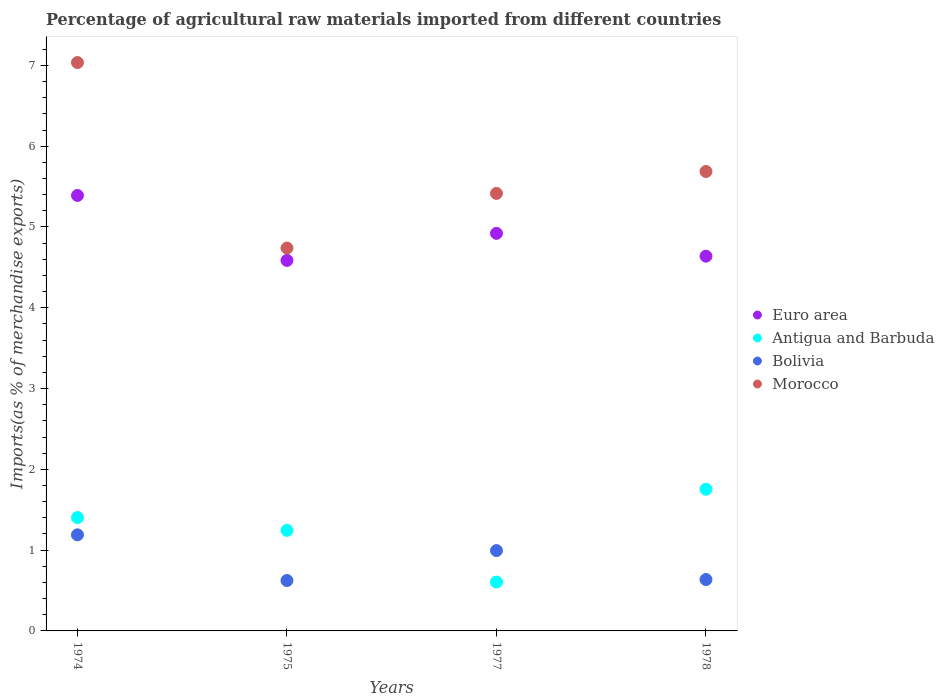What is the percentage of imports to different countries in Antigua and Barbuda in 1974?
Ensure brevity in your answer.  1.4. Across all years, what is the maximum percentage of imports to different countries in Morocco?
Your answer should be very brief. 7.04. Across all years, what is the minimum percentage of imports to different countries in Bolivia?
Keep it short and to the point. 0.62. In which year was the percentage of imports to different countries in Antigua and Barbuda maximum?
Make the answer very short. 1978. In which year was the percentage of imports to different countries in Bolivia minimum?
Make the answer very short. 1975. What is the total percentage of imports to different countries in Euro area in the graph?
Provide a succinct answer. 19.54. What is the difference between the percentage of imports to different countries in Morocco in 1974 and that in 1977?
Your response must be concise. 1.62. What is the difference between the percentage of imports to different countries in Antigua and Barbuda in 1978 and the percentage of imports to different countries in Euro area in 1974?
Provide a short and direct response. -3.64. What is the average percentage of imports to different countries in Bolivia per year?
Give a very brief answer. 0.86. In the year 1977, what is the difference between the percentage of imports to different countries in Euro area and percentage of imports to different countries in Bolivia?
Your answer should be very brief. 3.93. What is the ratio of the percentage of imports to different countries in Antigua and Barbuda in 1977 to that in 1978?
Your answer should be compact. 0.34. Is the difference between the percentage of imports to different countries in Euro area in 1975 and 1977 greater than the difference between the percentage of imports to different countries in Bolivia in 1975 and 1977?
Your response must be concise. Yes. What is the difference between the highest and the second highest percentage of imports to different countries in Bolivia?
Give a very brief answer. 0.2. What is the difference between the highest and the lowest percentage of imports to different countries in Bolivia?
Offer a very short reply. 0.57. In how many years, is the percentage of imports to different countries in Bolivia greater than the average percentage of imports to different countries in Bolivia taken over all years?
Your answer should be compact. 2. How many dotlines are there?
Keep it short and to the point. 4. How many years are there in the graph?
Provide a short and direct response. 4. Are the values on the major ticks of Y-axis written in scientific E-notation?
Provide a short and direct response. No. Does the graph contain grids?
Ensure brevity in your answer.  No. How many legend labels are there?
Ensure brevity in your answer.  4. What is the title of the graph?
Your response must be concise. Percentage of agricultural raw materials imported from different countries. What is the label or title of the X-axis?
Provide a succinct answer. Years. What is the label or title of the Y-axis?
Offer a very short reply. Imports(as % of merchandise exports). What is the Imports(as % of merchandise exports) of Euro area in 1974?
Your answer should be compact. 5.39. What is the Imports(as % of merchandise exports) in Antigua and Barbuda in 1974?
Your answer should be very brief. 1.4. What is the Imports(as % of merchandise exports) of Bolivia in 1974?
Offer a terse response. 1.19. What is the Imports(as % of merchandise exports) of Morocco in 1974?
Ensure brevity in your answer.  7.04. What is the Imports(as % of merchandise exports) in Euro area in 1975?
Provide a short and direct response. 4.59. What is the Imports(as % of merchandise exports) in Antigua and Barbuda in 1975?
Provide a succinct answer. 1.25. What is the Imports(as % of merchandise exports) in Bolivia in 1975?
Your response must be concise. 0.62. What is the Imports(as % of merchandise exports) of Morocco in 1975?
Provide a succinct answer. 4.74. What is the Imports(as % of merchandise exports) in Euro area in 1977?
Your response must be concise. 4.92. What is the Imports(as % of merchandise exports) in Antigua and Barbuda in 1977?
Offer a terse response. 0.6. What is the Imports(as % of merchandise exports) of Bolivia in 1977?
Make the answer very short. 0.99. What is the Imports(as % of merchandise exports) of Morocco in 1977?
Provide a succinct answer. 5.42. What is the Imports(as % of merchandise exports) of Euro area in 1978?
Your answer should be compact. 4.64. What is the Imports(as % of merchandise exports) of Antigua and Barbuda in 1978?
Your response must be concise. 1.75. What is the Imports(as % of merchandise exports) of Bolivia in 1978?
Provide a short and direct response. 0.64. What is the Imports(as % of merchandise exports) of Morocco in 1978?
Give a very brief answer. 5.69. Across all years, what is the maximum Imports(as % of merchandise exports) in Euro area?
Ensure brevity in your answer.  5.39. Across all years, what is the maximum Imports(as % of merchandise exports) of Antigua and Barbuda?
Your answer should be very brief. 1.75. Across all years, what is the maximum Imports(as % of merchandise exports) in Bolivia?
Your answer should be compact. 1.19. Across all years, what is the maximum Imports(as % of merchandise exports) in Morocco?
Your answer should be very brief. 7.04. Across all years, what is the minimum Imports(as % of merchandise exports) of Euro area?
Provide a succinct answer. 4.59. Across all years, what is the minimum Imports(as % of merchandise exports) in Antigua and Barbuda?
Your response must be concise. 0.6. Across all years, what is the minimum Imports(as % of merchandise exports) in Bolivia?
Ensure brevity in your answer.  0.62. Across all years, what is the minimum Imports(as % of merchandise exports) of Morocco?
Keep it short and to the point. 4.74. What is the total Imports(as % of merchandise exports) in Euro area in the graph?
Keep it short and to the point. 19.54. What is the total Imports(as % of merchandise exports) in Antigua and Barbuda in the graph?
Give a very brief answer. 5.01. What is the total Imports(as % of merchandise exports) in Bolivia in the graph?
Ensure brevity in your answer.  3.44. What is the total Imports(as % of merchandise exports) of Morocco in the graph?
Provide a succinct answer. 22.88. What is the difference between the Imports(as % of merchandise exports) of Euro area in 1974 and that in 1975?
Offer a terse response. 0.8. What is the difference between the Imports(as % of merchandise exports) of Antigua and Barbuda in 1974 and that in 1975?
Your response must be concise. 0.16. What is the difference between the Imports(as % of merchandise exports) of Bolivia in 1974 and that in 1975?
Ensure brevity in your answer.  0.57. What is the difference between the Imports(as % of merchandise exports) in Morocco in 1974 and that in 1975?
Offer a very short reply. 2.3. What is the difference between the Imports(as % of merchandise exports) of Euro area in 1974 and that in 1977?
Make the answer very short. 0.47. What is the difference between the Imports(as % of merchandise exports) in Antigua and Barbuda in 1974 and that in 1977?
Give a very brief answer. 0.8. What is the difference between the Imports(as % of merchandise exports) of Bolivia in 1974 and that in 1977?
Offer a very short reply. 0.2. What is the difference between the Imports(as % of merchandise exports) in Morocco in 1974 and that in 1977?
Offer a terse response. 1.62. What is the difference between the Imports(as % of merchandise exports) in Euro area in 1974 and that in 1978?
Your response must be concise. 0.75. What is the difference between the Imports(as % of merchandise exports) in Antigua and Barbuda in 1974 and that in 1978?
Provide a short and direct response. -0.35. What is the difference between the Imports(as % of merchandise exports) of Bolivia in 1974 and that in 1978?
Make the answer very short. 0.55. What is the difference between the Imports(as % of merchandise exports) in Morocco in 1974 and that in 1978?
Provide a short and direct response. 1.35. What is the difference between the Imports(as % of merchandise exports) of Euro area in 1975 and that in 1977?
Keep it short and to the point. -0.33. What is the difference between the Imports(as % of merchandise exports) in Antigua and Barbuda in 1975 and that in 1977?
Provide a succinct answer. 0.64. What is the difference between the Imports(as % of merchandise exports) in Bolivia in 1975 and that in 1977?
Your answer should be very brief. -0.37. What is the difference between the Imports(as % of merchandise exports) of Morocco in 1975 and that in 1977?
Provide a succinct answer. -0.68. What is the difference between the Imports(as % of merchandise exports) of Euro area in 1975 and that in 1978?
Provide a short and direct response. -0.05. What is the difference between the Imports(as % of merchandise exports) in Antigua and Barbuda in 1975 and that in 1978?
Offer a very short reply. -0.51. What is the difference between the Imports(as % of merchandise exports) of Bolivia in 1975 and that in 1978?
Offer a terse response. -0.01. What is the difference between the Imports(as % of merchandise exports) in Morocco in 1975 and that in 1978?
Your answer should be very brief. -0.95. What is the difference between the Imports(as % of merchandise exports) of Euro area in 1977 and that in 1978?
Give a very brief answer. 0.28. What is the difference between the Imports(as % of merchandise exports) of Antigua and Barbuda in 1977 and that in 1978?
Your answer should be compact. -1.15. What is the difference between the Imports(as % of merchandise exports) in Bolivia in 1977 and that in 1978?
Make the answer very short. 0.36. What is the difference between the Imports(as % of merchandise exports) in Morocco in 1977 and that in 1978?
Make the answer very short. -0.27. What is the difference between the Imports(as % of merchandise exports) of Euro area in 1974 and the Imports(as % of merchandise exports) of Antigua and Barbuda in 1975?
Your answer should be very brief. 4.15. What is the difference between the Imports(as % of merchandise exports) of Euro area in 1974 and the Imports(as % of merchandise exports) of Bolivia in 1975?
Make the answer very short. 4.77. What is the difference between the Imports(as % of merchandise exports) in Euro area in 1974 and the Imports(as % of merchandise exports) in Morocco in 1975?
Your response must be concise. 0.65. What is the difference between the Imports(as % of merchandise exports) in Antigua and Barbuda in 1974 and the Imports(as % of merchandise exports) in Bolivia in 1975?
Your answer should be compact. 0.78. What is the difference between the Imports(as % of merchandise exports) of Antigua and Barbuda in 1974 and the Imports(as % of merchandise exports) of Morocco in 1975?
Offer a terse response. -3.34. What is the difference between the Imports(as % of merchandise exports) of Bolivia in 1974 and the Imports(as % of merchandise exports) of Morocco in 1975?
Keep it short and to the point. -3.55. What is the difference between the Imports(as % of merchandise exports) in Euro area in 1974 and the Imports(as % of merchandise exports) in Antigua and Barbuda in 1977?
Make the answer very short. 4.79. What is the difference between the Imports(as % of merchandise exports) of Euro area in 1974 and the Imports(as % of merchandise exports) of Bolivia in 1977?
Provide a succinct answer. 4.4. What is the difference between the Imports(as % of merchandise exports) of Euro area in 1974 and the Imports(as % of merchandise exports) of Morocco in 1977?
Keep it short and to the point. -0.03. What is the difference between the Imports(as % of merchandise exports) in Antigua and Barbuda in 1974 and the Imports(as % of merchandise exports) in Bolivia in 1977?
Provide a succinct answer. 0.41. What is the difference between the Imports(as % of merchandise exports) in Antigua and Barbuda in 1974 and the Imports(as % of merchandise exports) in Morocco in 1977?
Ensure brevity in your answer.  -4.01. What is the difference between the Imports(as % of merchandise exports) of Bolivia in 1974 and the Imports(as % of merchandise exports) of Morocco in 1977?
Keep it short and to the point. -4.23. What is the difference between the Imports(as % of merchandise exports) of Euro area in 1974 and the Imports(as % of merchandise exports) of Antigua and Barbuda in 1978?
Your answer should be compact. 3.64. What is the difference between the Imports(as % of merchandise exports) in Euro area in 1974 and the Imports(as % of merchandise exports) in Bolivia in 1978?
Make the answer very short. 4.75. What is the difference between the Imports(as % of merchandise exports) of Euro area in 1974 and the Imports(as % of merchandise exports) of Morocco in 1978?
Make the answer very short. -0.3. What is the difference between the Imports(as % of merchandise exports) of Antigua and Barbuda in 1974 and the Imports(as % of merchandise exports) of Bolivia in 1978?
Your answer should be very brief. 0.77. What is the difference between the Imports(as % of merchandise exports) in Antigua and Barbuda in 1974 and the Imports(as % of merchandise exports) in Morocco in 1978?
Your answer should be compact. -4.28. What is the difference between the Imports(as % of merchandise exports) of Bolivia in 1974 and the Imports(as % of merchandise exports) of Morocco in 1978?
Ensure brevity in your answer.  -4.5. What is the difference between the Imports(as % of merchandise exports) of Euro area in 1975 and the Imports(as % of merchandise exports) of Antigua and Barbuda in 1977?
Give a very brief answer. 3.98. What is the difference between the Imports(as % of merchandise exports) of Euro area in 1975 and the Imports(as % of merchandise exports) of Bolivia in 1977?
Provide a succinct answer. 3.59. What is the difference between the Imports(as % of merchandise exports) in Euro area in 1975 and the Imports(as % of merchandise exports) in Morocco in 1977?
Offer a terse response. -0.83. What is the difference between the Imports(as % of merchandise exports) of Antigua and Barbuda in 1975 and the Imports(as % of merchandise exports) of Bolivia in 1977?
Provide a short and direct response. 0.25. What is the difference between the Imports(as % of merchandise exports) in Antigua and Barbuda in 1975 and the Imports(as % of merchandise exports) in Morocco in 1977?
Your answer should be very brief. -4.17. What is the difference between the Imports(as % of merchandise exports) in Bolivia in 1975 and the Imports(as % of merchandise exports) in Morocco in 1977?
Ensure brevity in your answer.  -4.79. What is the difference between the Imports(as % of merchandise exports) in Euro area in 1975 and the Imports(as % of merchandise exports) in Antigua and Barbuda in 1978?
Your answer should be compact. 2.83. What is the difference between the Imports(as % of merchandise exports) in Euro area in 1975 and the Imports(as % of merchandise exports) in Bolivia in 1978?
Your response must be concise. 3.95. What is the difference between the Imports(as % of merchandise exports) in Euro area in 1975 and the Imports(as % of merchandise exports) in Morocco in 1978?
Provide a succinct answer. -1.1. What is the difference between the Imports(as % of merchandise exports) in Antigua and Barbuda in 1975 and the Imports(as % of merchandise exports) in Bolivia in 1978?
Your answer should be very brief. 0.61. What is the difference between the Imports(as % of merchandise exports) of Antigua and Barbuda in 1975 and the Imports(as % of merchandise exports) of Morocco in 1978?
Your response must be concise. -4.44. What is the difference between the Imports(as % of merchandise exports) of Bolivia in 1975 and the Imports(as % of merchandise exports) of Morocco in 1978?
Your answer should be very brief. -5.06. What is the difference between the Imports(as % of merchandise exports) in Euro area in 1977 and the Imports(as % of merchandise exports) in Antigua and Barbuda in 1978?
Keep it short and to the point. 3.17. What is the difference between the Imports(as % of merchandise exports) of Euro area in 1977 and the Imports(as % of merchandise exports) of Bolivia in 1978?
Your answer should be very brief. 4.29. What is the difference between the Imports(as % of merchandise exports) of Euro area in 1977 and the Imports(as % of merchandise exports) of Morocco in 1978?
Ensure brevity in your answer.  -0.77. What is the difference between the Imports(as % of merchandise exports) in Antigua and Barbuda in 1977 and the Imports(as % of merchandise exports) in Bolivia in 1978?
Make the answer very short. -0.03. What is the difference between the Imports(as % of merchandise exports) in Antigua and Barbuda in 1977 and the Imports(as % of merchandise exports) in Morocco in 1978?
Your answer should be very brief. -5.08. What is the difference between the Imports(as % of merchandise exports) in Bolivia in 1977 and the Imports(as % of merchandise exports) in Morocco in 1978?
Provide a short and direct response. -4.69. What is the average Imports(as % of merchandise exports) in Euro area per year?
Make the answer very short. 4.88. What is the average Imports(as % of merchandise exports) of Antigua and Barbuda per year?
Offer a very short reply. 1.25. What is the average Imports(as % of merchandise exports) in Bolivia per year?
Keep it short and to the point. 0.86. What is the average Imports(as % of merchandise exports) in Morocco per year?
Offer a very short reply. 5.72. In the year 1974, what is the difference between the Imports(as % of merchandise exports) of Euro area and Imports(as % of merchandise exports) of Antigua and Barbuda?
Provide a short and direct response. 3.99. In the year 1974, what is the difference between the Imports(as % of merchandise exports) of Euro area and Imports(as % of merchandise exports) of Bolivia?
Offer a very short reply. 4.2. In the year 1974, what is the difference between the Imports(as % of merchandise exports) of Euro area and Imports(as % of merchandise exports) of Morocco?
Provide a succinct answer. -1.65. In the year 1974, what is the difference between the Imports(as % of merchandise exports) of Antigua and Barbuda and Imports(as % of merchandise exports) of Bolivia?
Provide a short and direct response. 0.21. In the year 1974, what is the difference between the Imports(as % of merchandise exports) of Antigua and Barbuda and Imports(as % of merchandise exports) of Morocco?
Keep it short and to the point. -5.63. In the year 1974, what is the difference between the Imports(as % of merchandise exports) of Bolivia and Imports(as % of merchandise exports) of Morocco?
Offer a very short reply. -5.85. In the year 1975, what is the difference between the Imports(as % of merchandise exports) in Euro area and Imports(as % of merchandise exports) in Antigua and Barbuda?
Make the answer very short. 3.34. In the year 1975, what is the difference between the Imports(as % of merchandise exports) in Euro area and Imports(as % of merchandise exports) in Bolivia?
Keep it short and to the point. 3.96. In the year 1975, what is the difference between the Imports(as % of merchandise exports) of Euro area and Imports(as % of merchandise exports) of Morocco?
Offer a terse response. -0.15. In the year 1975, what is the difference between the Imports(as % of merchandise exports) in Antigua and Barbuda and Imports(as % of merchandise exports) in Bolivia?
Provide a short and direct response. 0.62. In the year 1975, what is the difference between the Imports(as % of merchandise exports) of Antigua and Barbuda and Imports(as % of merchandise exports) of Morocco?
Provide a succinct answer. -3.49. In the year 1975, what is the difference between the Imports(as % of merchandise exports) in Bolivia and Imports(as % of merchandise exports) in Morocco?
Your answer should be compact. -4.12. In the year 1977, what is the difference between the Imports(as % of merchandise exports) of Euro area and Imports(as % of merchandise exports) of Antigua and Barbuda?
Give a very brief answer. 4.32. In the year 1977, what is the difference between the Imports(as % of merchandise exports) in Euro area and Imports(as % of merchandise exports) in Bolivia?
Your answer should be very brief. 3.93. In the year 1977, what is the difference between the Imports(as % of merchandise exports) of Euro area and Imports(as % of merchandise exports) of Morocco?
Provide a succinct answer. -0.49. In the year 1977, what is the difference between the Imports(as % of merchandise exports) of Antigua and Barbuda and Imports(as % of merchandise exports) of Bolivia?
Make the answer very short. -0.39. In the year 1977, what is the difference between the Imports(as % of merchandise exports) in Antigua and Barbuda and Imports(as % of merchandise exports) in Morocco?
Keep it short and to the point. -4.81. In the year 1977, what is the difference between the Imports(as % of merchandise exports) in Bolivia and Imports(as % of merchandise exports) in Morocco?
Provide a short and direct response. -4.42. In the year 1978, what is the difference between the Imports(as % of merchandise exports) of Euro area and Imports(as % of merchandise exports) of Antigua and Barbuda?
Offer a very short reply. 2.88. In the year 1978, what is the difference between the Imports(as % of merchandise exports) of Euro area and Imports(as % of merchandise exports) of Bolivia?
Provide a succinct answer. 4. In the year 1978, what is the difference between the Imports(as % of merchandise exports) in Euro area and Imports(as % of merchandise exports) in Morocco?
Make the answer very short. -1.05. In the year 1978, what is the difference between the Imports(as % of merchandise exports) of Antigua and Barbuda and Imports(as % of merchandise exports) of Bolivia?
Offer a terse response. 1.12. In the year 1978, what is the difference between the Imports(as % of merchandise exports) of Antigua and Barbuda and Imports(as % of merchandise exports) of Morocco?
Provide a short and direct response. -3.93. In the year 1978, what is the difference between the Imports(as % of merchandise exports) of Bolivia and Imports(as % of merchandise exports) of Morocco?
Provide a short and direct response. -5.05. What is the ratio of the Imports(as % of merchandise exports) of Euro area in 1974 to that in 1975?
Make the answer very short. 1.18. What is the ratio of the Imports(as % of merchandise exports) of Antigua and Barbuda in 1974 to that in 1975?
Offer a very short reply. 1.13. What is the ratio of the Imports(as % of merchandise exports) in Bolivia in 1974 to that in 1975?
Give a very brief answer. 1.91. What is the ratio of the Imports(as % of merchandise exports) of Morocco in 1974 to that in 1975?
Keep it short and to the point. 1.48. What is the ratio of the Imports(as % of merchandise exports) in Euro area in 1974 to that in 1977?
Offer a terse response. 1.1. What is the ratio of the Imports(as % of merchandise exports) of Antigua and Barbuda in 1974 to that in 1977?
Ensure brevity in your answer.  2.32. What is the ratio of the Imports(as % of merchandise exports) of Bolivia in 1974 to that in 1977?
Ensure brevity in your answer.  1.2. What is the ratio of the Imports(as % of merchandise exports) of Morocco in 1974 to that in 1977?
Ensure brevity in your answer.  1.3. What is the ratio of the Imports(as % of merchandise exports) in Euro area in 1974 to that in 1978?
Keep it short and to the point. 1.16. What is the ratio of the Imports(as % of merchandise exports) in Antigua and Barbuda in 1974 to that in 1978?
Your answer should be compact. 0.8. What is the ratio of the Imports(as % of merchandise exports) in Bolivia in 1974 to that in 1978?
Offer a very short reply. 1.87. What is the ratio of the Imports(as % of merchandise exports) of Morocco in 1974 to that in 1978?
Keep it short and to the point. 1.24. What is the ratio of the Imports(as % of merchandise exports) of Euro area in 1975 to that in 1977?
Your answer should be compact. 0.93. What is the ratio of the Imports(as % of merchandise exports) of Antigua and Barbuda in 1975 to that in 1977?
Make the answer very short. 2.06. What is the ratio of the Imports(as % of merchandise exports) in Bolivia in 1975 to that in 1977?
Your answer should be very brief. 0.63. What is the ratio of the Imports(as % of merchandise exports) in Morocco in 1975 to that in 1977?
Provide a short and direct response. 0.88. What is the ratio of the Imports(as % of merchandise exports) in Euro area in 1975 to that in 1978?
Give a very brief answer. 0.99. What is the ratio of the Imports(as % of merchandise exports) of Antigua and Barbuda in 1975 to that in 1978?
Keep it short and to the point. 0.71. What is the ratio of the Imports(as % of merchandise exports) of Bolivia in 1975 to that in 1978?
Provide a short and direct response. 0.98. What is the ratio of the Imports(as % of merchandise exports) in Morocco in 1975 to that in 1978?
Ensure brevity in your answer.  0.83. What is the ratio of the Imports(as % of merchandise exports) of Euro area in 1977 to that in 1978?
Offer a very short reply. 1.06. What is the ratio of the Imports(as % of merchandise exports) of Antigua and Barbuda in 1977 to that in 1978?
Make the answer very short. 0.34. What is the ratio of the Imports(as % of merchandise exports) of Bolivia in 1977 to that in 1978?
Provide a succinct answer. 1.56. What is the ratio of the Imports(as % of merchandise exports) of Morocco in 1977 to that in 1978?
Your response must be concise. 0.95. What is the difference between the highest and the second highest Imports(as % of merchandise exports) in Euro area?
Give a very brief answer. 0.47. What is the difference between the highest and the second highest Imports(as % of merchandise exports) in Antigua and Barbuda?
Your answer should be very brief. 0.35. What is the difference between the highest and the second highest Imports(as % of merchandise exports) in Bolivia?
Provide a succinct answer. 0.2. What is the difference between the highest and the second highest Imports(as % of merchandise exports) in Morocco?
Your answer should be compact. 1.35. What is the difference between the highest and the lowest Imports(as % of merchandise exports) of Euro area?
Keep it short and to the point. 0.8. What is the difference between the highest and the lowest Imports(as % of merchandise exports) of Antigua and Barbuda?
Your response must be concise. 1.15. What is the difference between the highest and the lowest Imports(as % of merchandise exports) in Bolivia?
Provide a short and direct response. 0.57. What is the difference between the highest and the lowest Imports(as % of merchandise exports) of Morocco?
Offer a terse response. 2.3. 